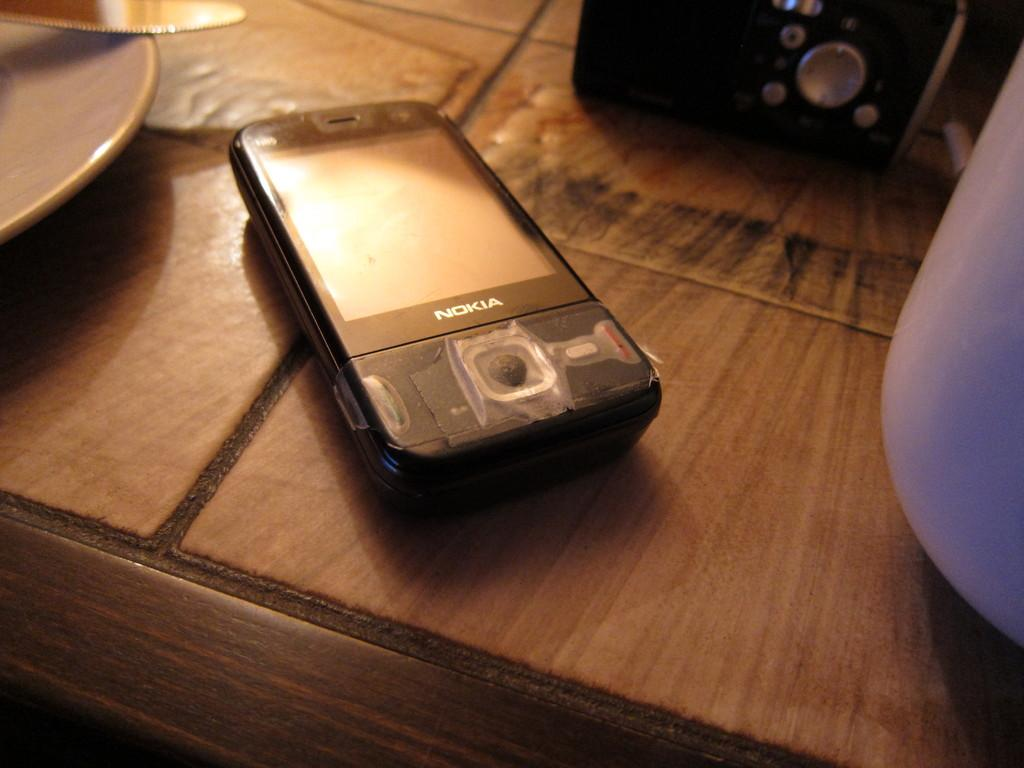<image>
Provide a brief description of the given image. A Nokia cell phone sitting on a table next to radio 